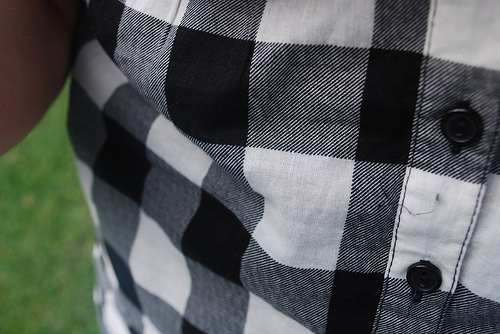<image>
Is the button next to the stitch? No. The button is not positioned next to the stitch. They are located in different areas of the scene. 